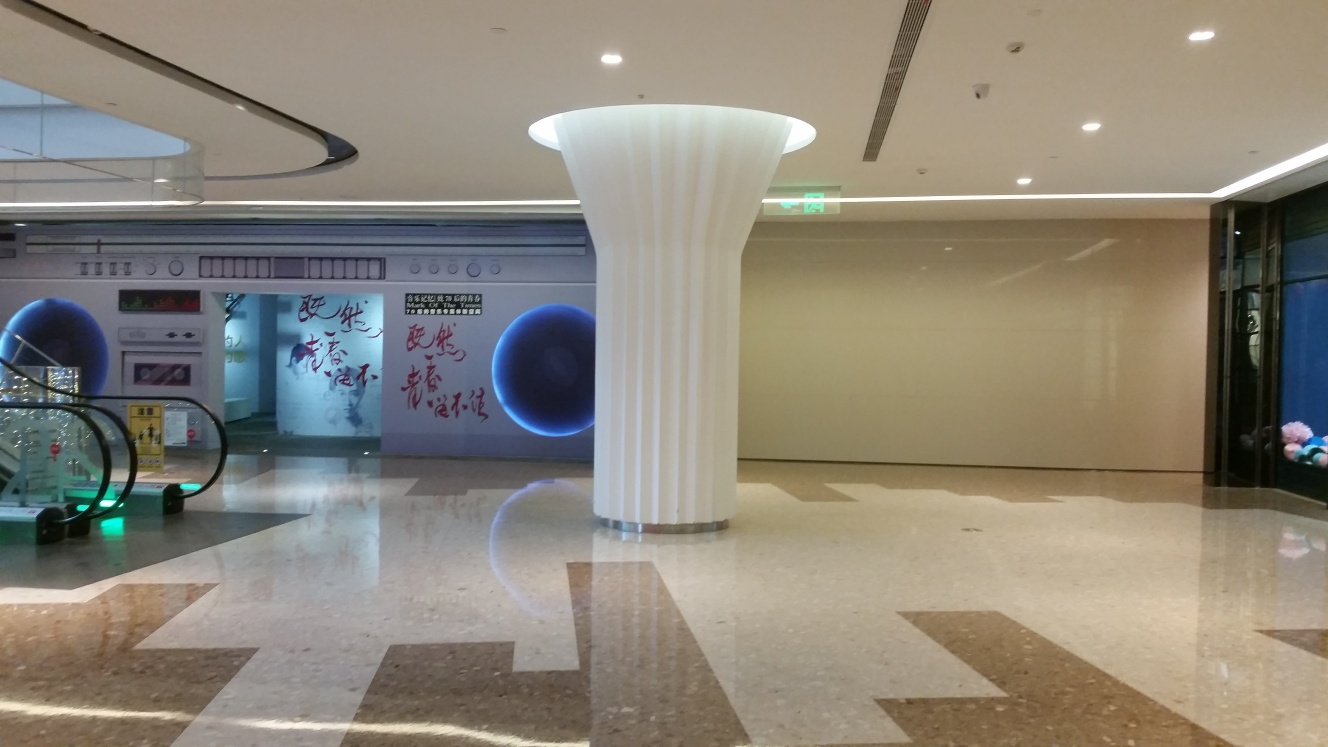What could be the purpose of the blue object in the background? The large blue object appears to be a decorative installation or part of an interactive exhibit within the building, possibly intended to attract and engage visitors. 